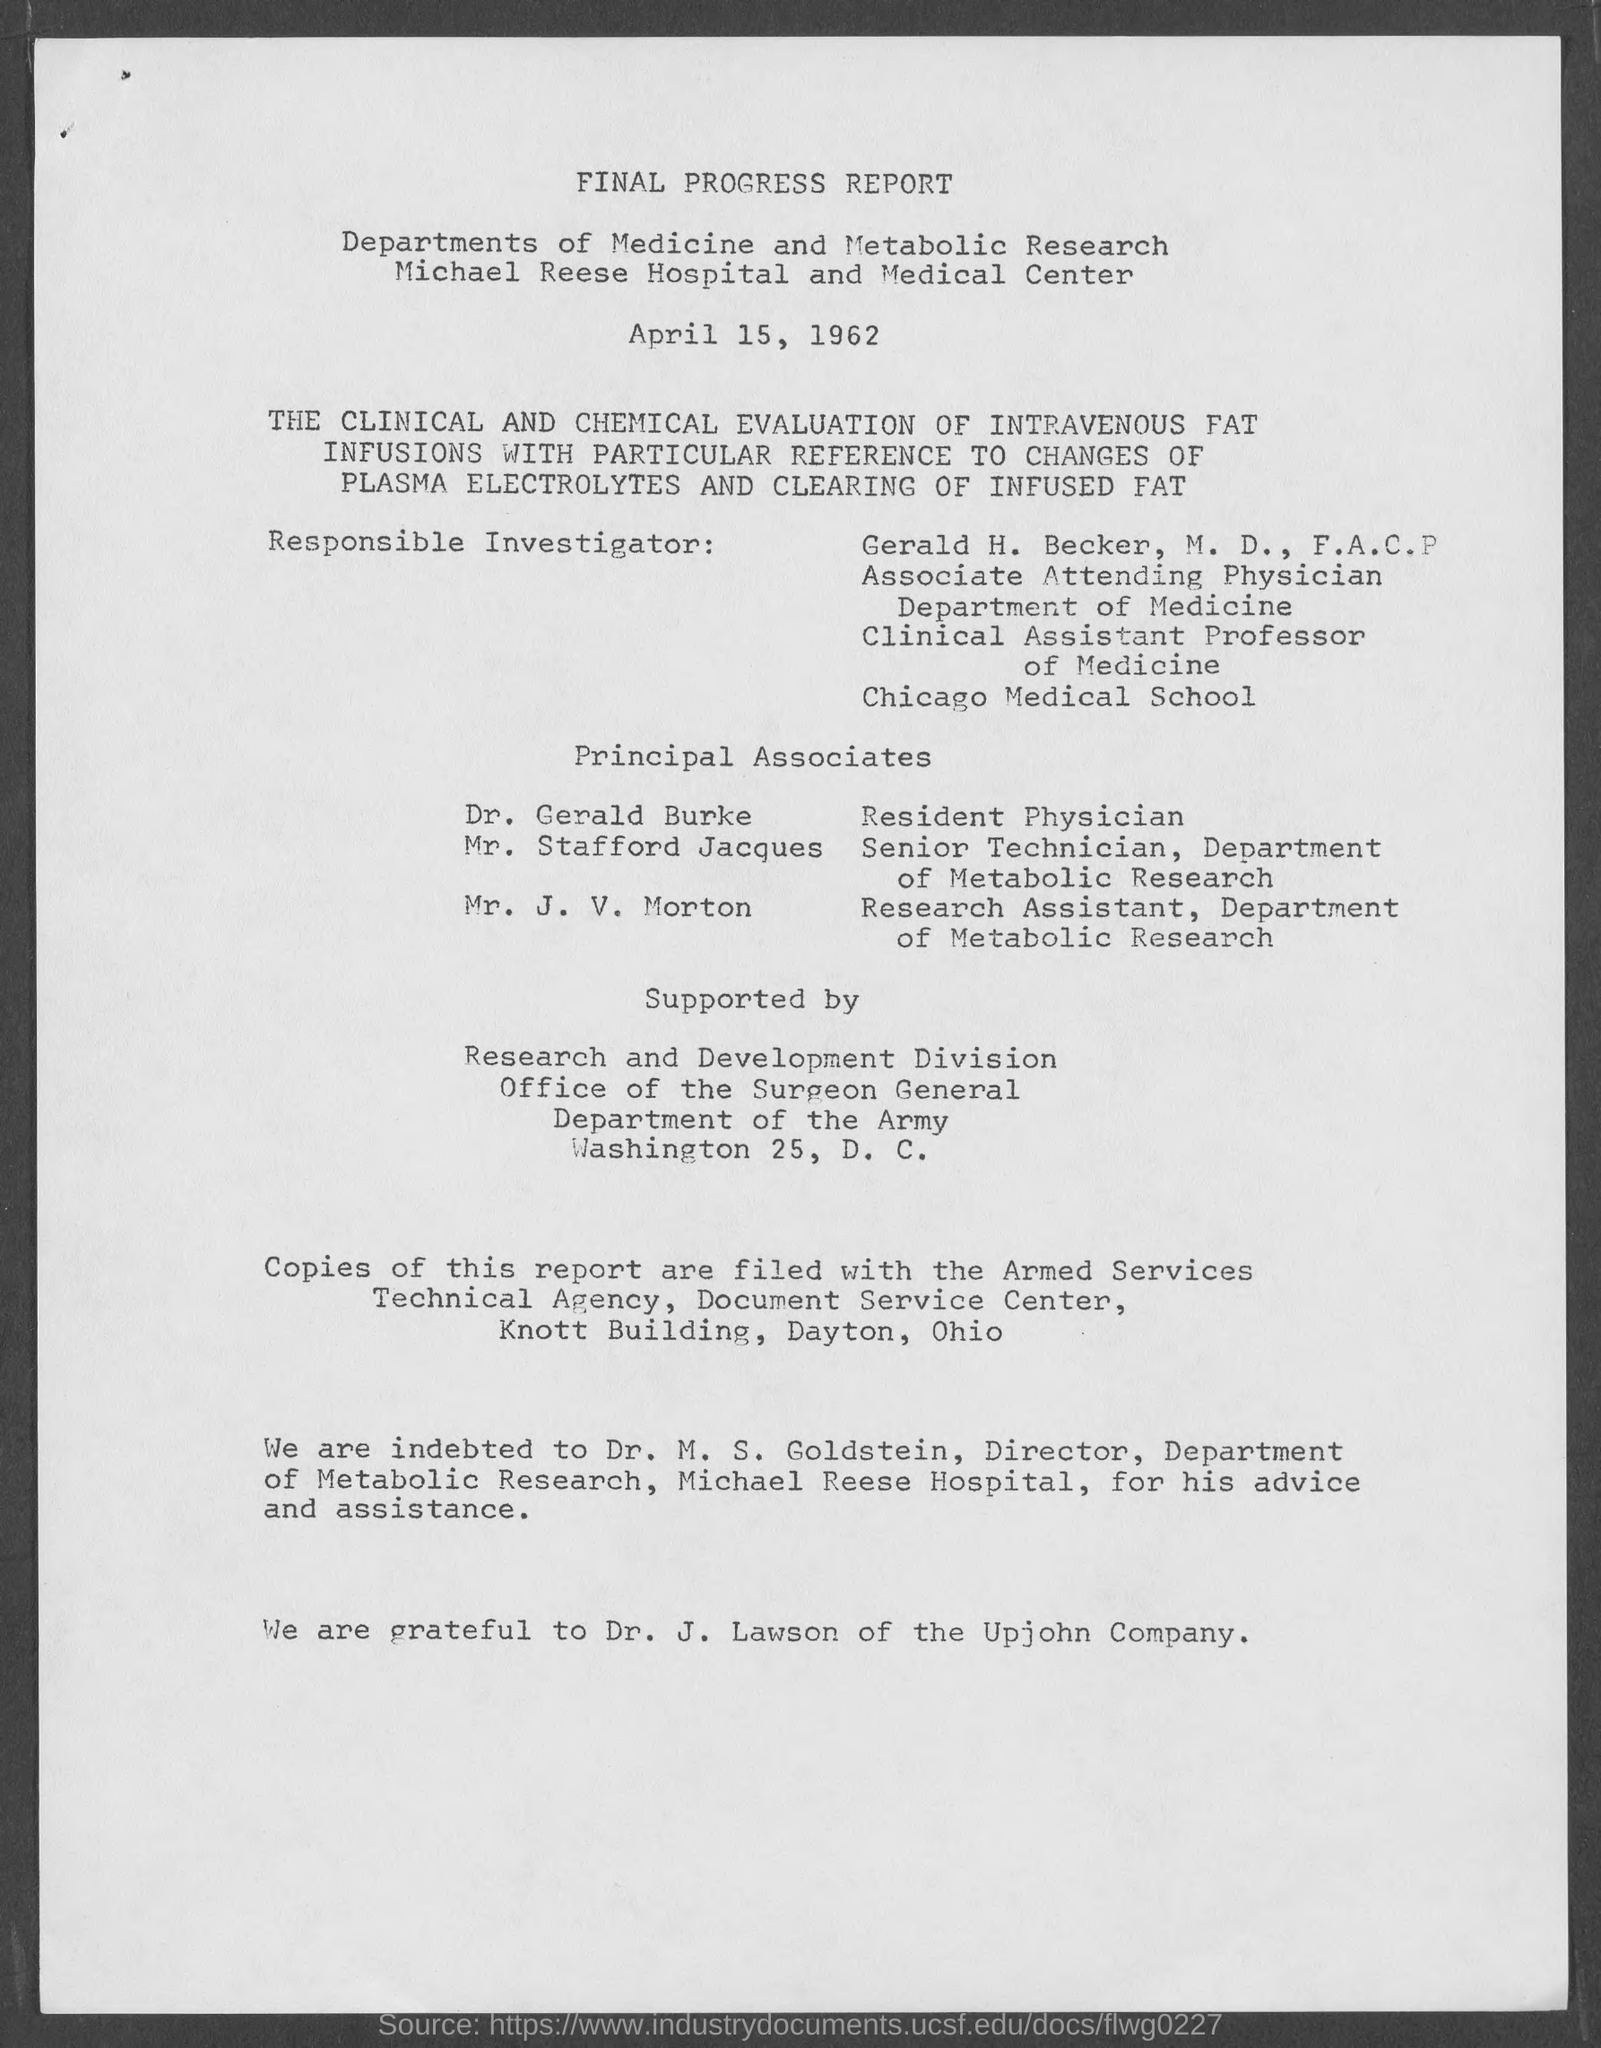Outline some significant characteristics in this image. Dr. J. Lawson is affiliated with the Upjohn company. The date of the report is April 15, 1962. 